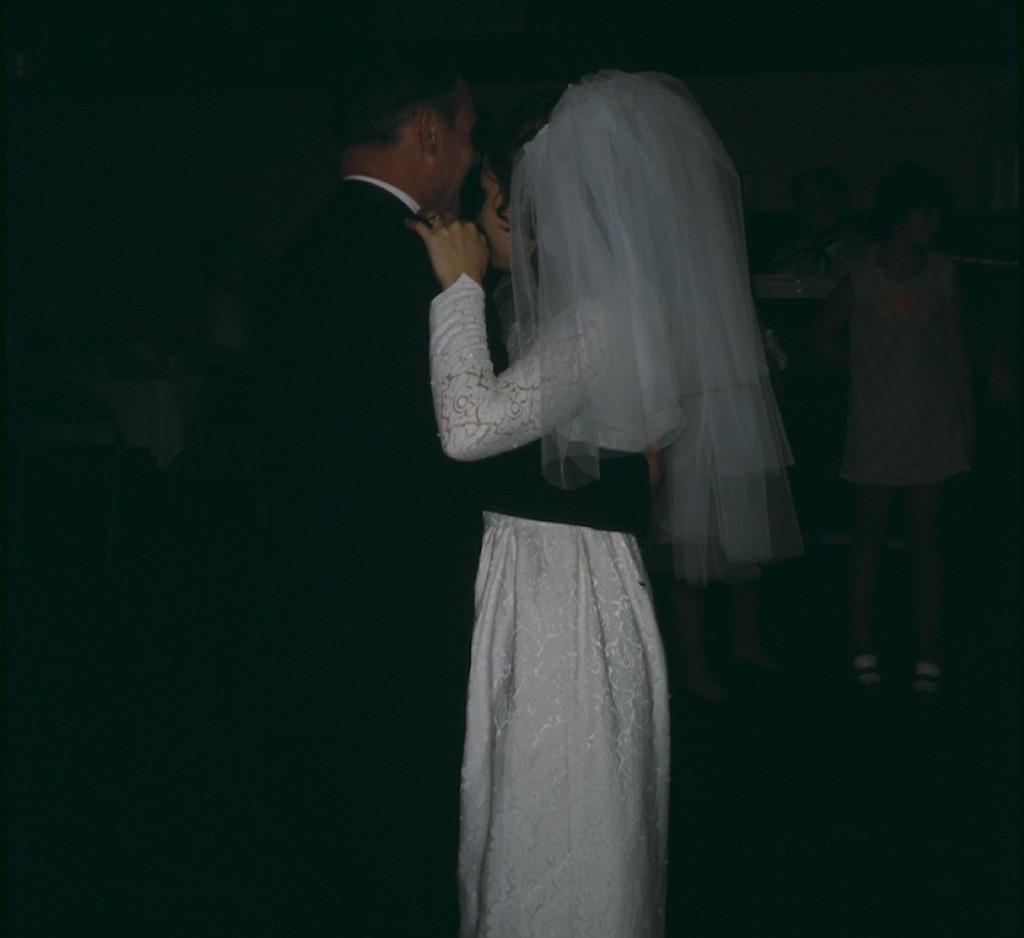How would you summarize this image in a sentence or two? This picture seems to be clicked inside the room and we can see the group of people. In the foreground we can see a person wearing a suit and we can see a woman wearing a white color dress, standing and both of them seems to be dancing with each other. In the background we can see the group of people seems to be standing on the floor and we can see the chair, table on the top of which some items are placed and we can see the wall and some other objects in the background. 